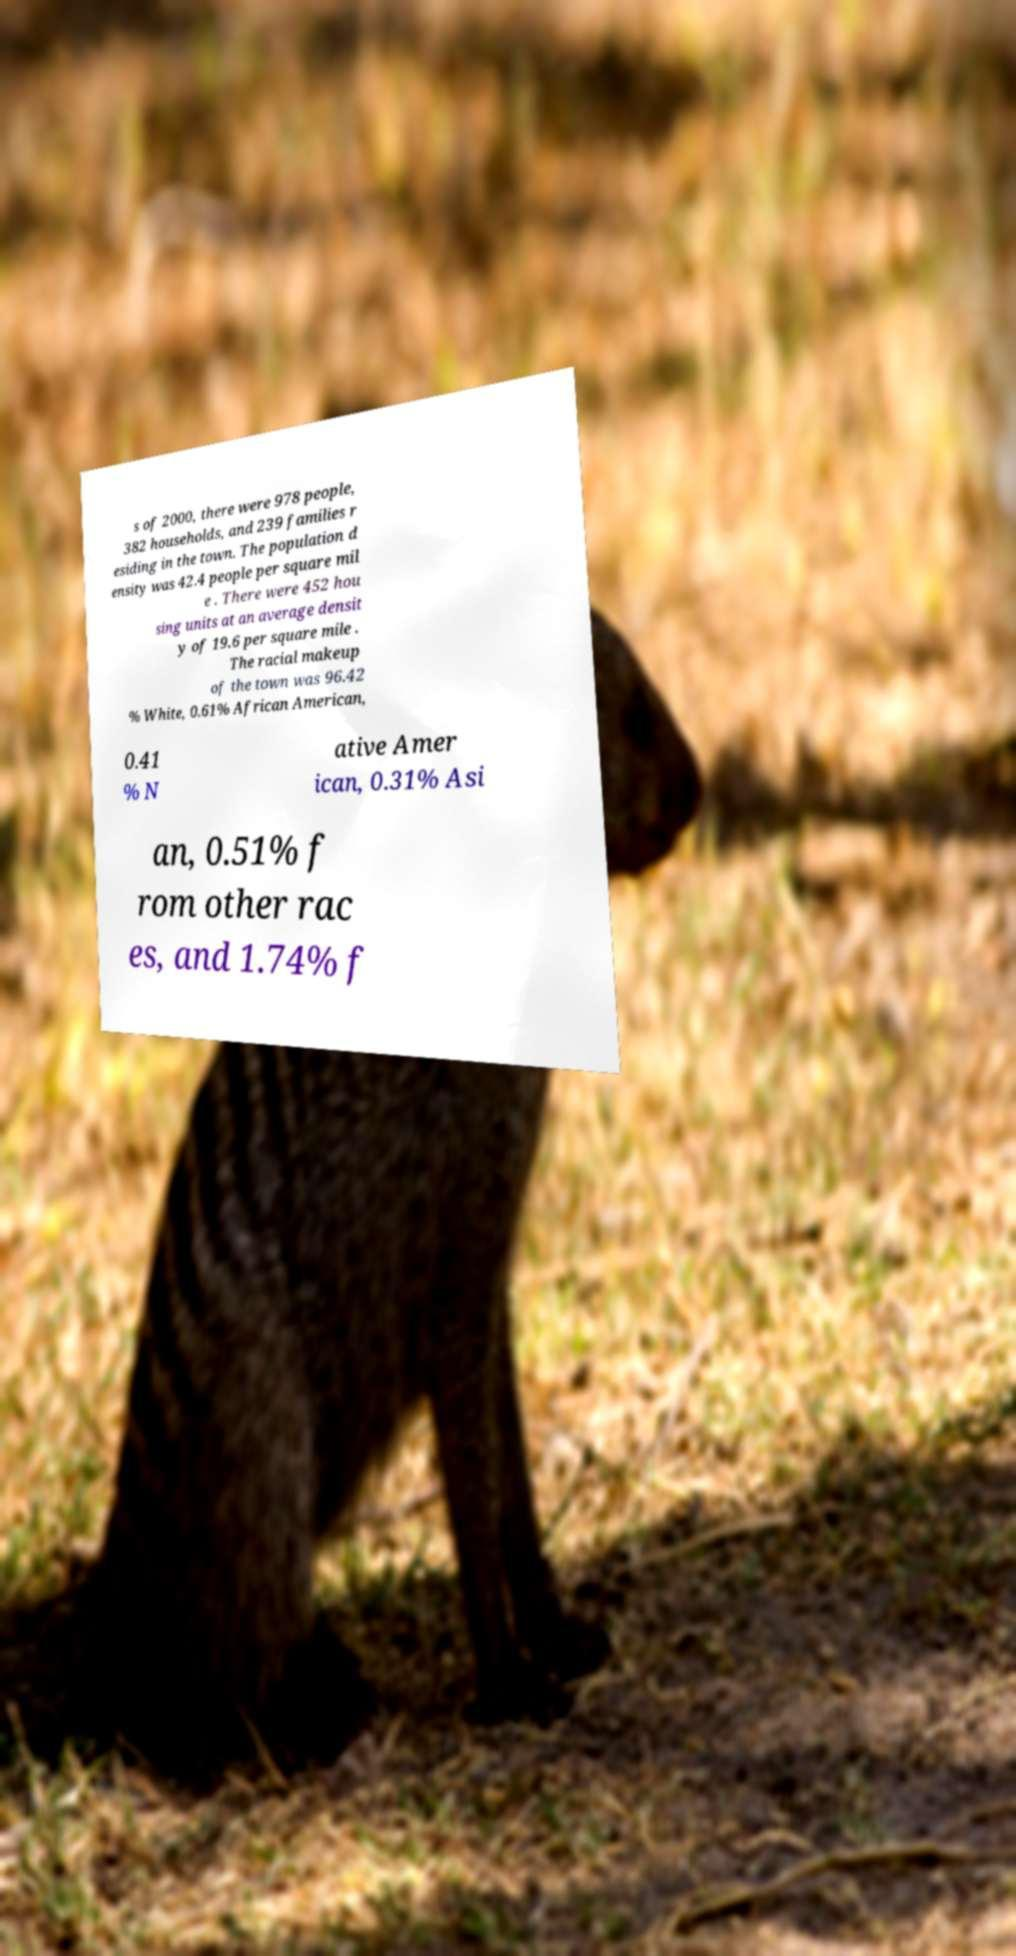Can you accurately transcribe the text from the provided image for me? s of 2000, there were 978 people, 382 households, and 239 families r esiding in the town. The population d ensity was 42.4 people per square mil e . There were 452 hou sing units at an average densit y of 19.6 per square mile . The racial makeup of the town was 96.42 % White, 0.61% African American, 0.41 % N ative Amer ican, 0.31% Asi an, 0.51% f rom other rac es, and 1.74% f 